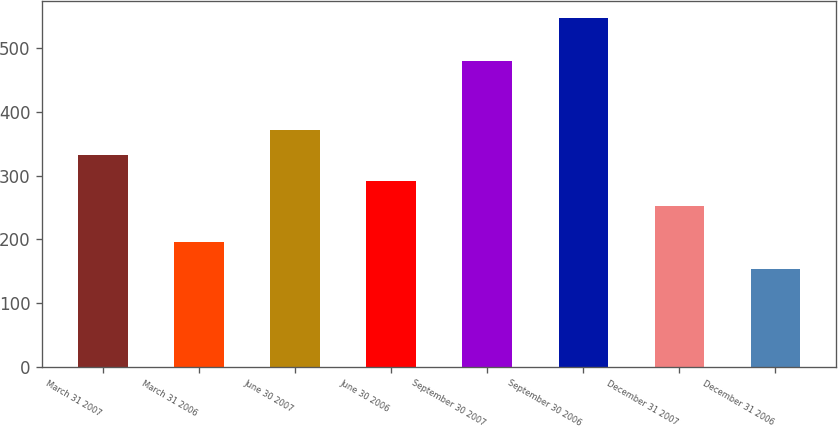Convert chart. <chart><loc_0><loc_0><loc_500><loc_500><bar_chart><fcel>March 31 2007<fcel>March 31 2006<fcel>June 30 2007<fcel>June 30 2006<fcel>September 30 2007<fcel>September 30 2006<fcel>December 31 2007<fcel>December 31 2006<nl><fcel>331.6<fcel>196<fcel>370.9<fcel>292.3<fcel>479<fcel>547<fcel>253<fcel>154<nl></chart> 